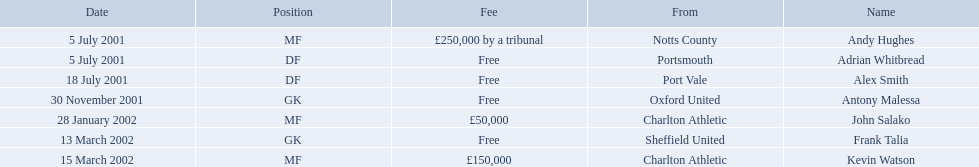List all the players names Andy Hughes, Adrian Whitbread, Alex Smith, Antony Malessa, John Salako, Frank Talia, Kevin Watson. Of these who is kevin watson Kevin Watson. To what transfer fee entry does kevin correspond to? £150,000. 